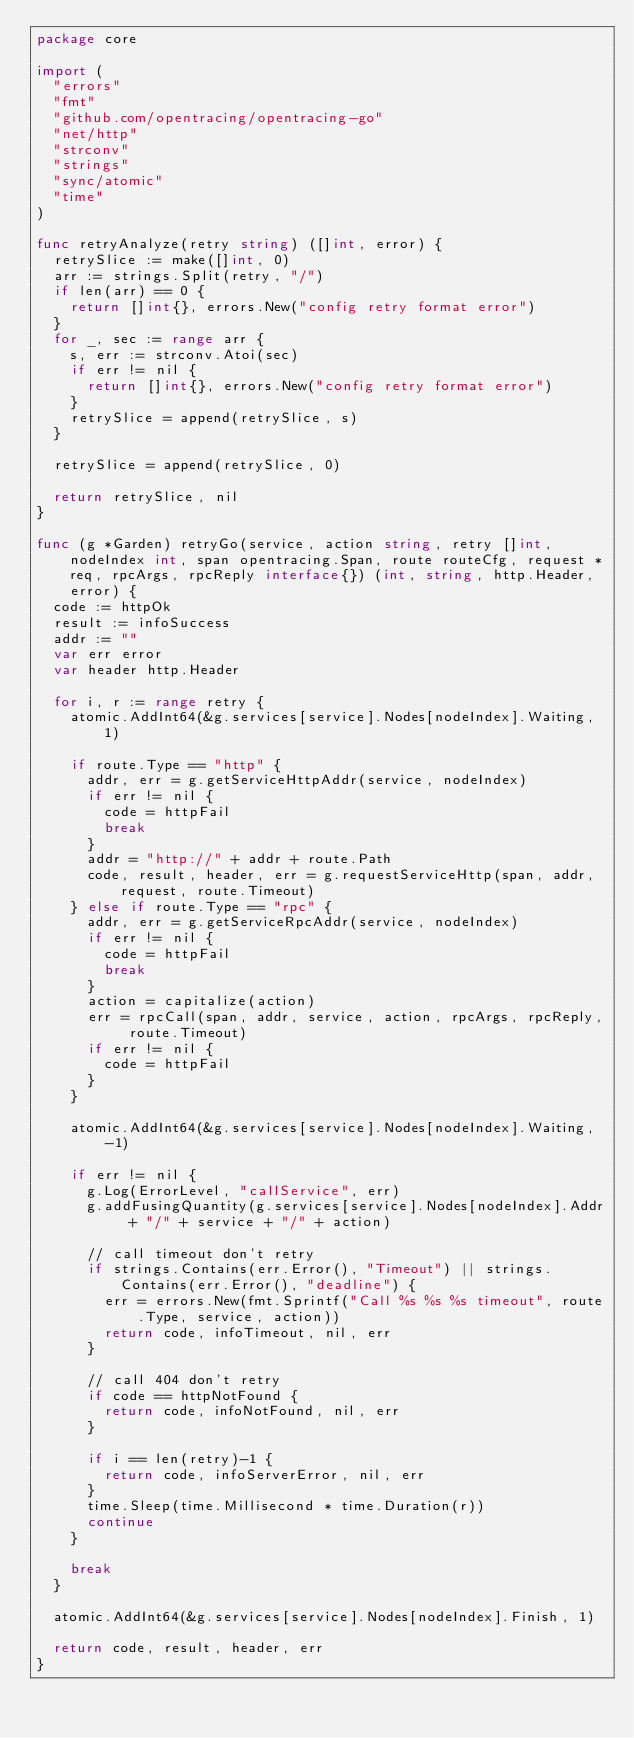<code> <loc_0><loc_0><loc_500><loc_500><_Go_>package core

import (
	"errors"
	"fmt"
	"github.com/opentracing/opentracing-go"
	"net/http"
	"strconv"
	"strings"
	"sync/atomic"
	"time"
)

func retryAnalyze(retry string) ([]int, error) {
	retrySlice := make([]int, 0)
	arr := strings.Split(retry, "/")
	if len(arr) == 0 {
		return []int{}, errors.New("config retry format error")
	}
	for _, sec := range arr {
		s, err := strconv.Atoi(sec)
		if err != nil {
			return []int{}, errors.New("config retry format error")
		}
		retrySlice = append(retrySlice, s)
	}

	retrySlice = append(retrySlice, 0)

	return retrySlice, nil
}

func (g *Garden) retryGo(service, action string, retry []int, nodeIndex int, span opentracing.Span, route routeCfg, request *req, rpcArgs, rpcReply interface{}) (int, string, http.Header, error) {
	code := httpOk
	result := infoSuccess
	addr := ""
	var err error
	var header http.Header

	for i, r := range retry {
		atomic.AddInt64(&g.services[service].Nodes[nodeIndex].Waiting, 1)

		if route.Type == "http" {
			addr, err = g.getServiceHttpAddr(service, nodeIndex)
			if err != nil {
				code = httpFail
				break
			}
			addr = "http://" + addr + route.Path
			code, result, header, err = g.requestServiceHttp(span, addr, request, route.Timeout)
		} else if route.Type == "rpc" {
			addr, err = g.getServiceRpcAddr(service, nodeIndex)
			if err != nil {
				code = httpFail
				break
			}
			action = capitalize(action)
			err = rpcCall(span, addr, service, action, rpcArgs, rpcReply, route.Timeout)
			if err != nil {
				code = httpFail
			}
		}

		atomic.AddInt64(&g.services[service].Nodes[nodeIndex].Waiting, -1)

		if err != nil {
			g.Log(ErrorLevel, "callService", err)
			g.addFusingQuantity(g.services[service].Nodes[nodeIndex].Addr + "/" + service + "/" + action)

			// call timeout don't retry
			if strings.Contains(err.Error(), "Timeout") || strings.Contains(err.Error(), "deadline") {
				err = errors.New(fmt.Sprintf("Call %s %s %s timeout", route.Type, service, action))
				return code, infoTimeout, nil, err
			}

			// call 404 don't retry
			if code == httpNotFound {
				return code, infoNotFound, nil, err
			}

			if i == len(retry)-1 {
				return code, infoServerError, nil, err
			}
			time.Sleep(time.Millisecond * time.Duration(r))
			continue
		}

		break
	}

	atomic.AddInt64(&g.services[service].Nodes[nodeIndex].Finish, 1)

	return code, result, header, err
}
</code> 